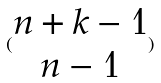<formula> <loc_0><loc_0><loc_500><loc_500>( \begin{matrix} n + k - 1 \\ n - 1 \end{matrix} )</formula> 